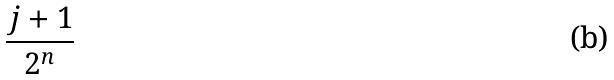Convert formula to latex. <formula><loc_0><loc_0><loc_500><loc_500>\frac { j + 1 } { 2 ^ { n } }</formula> 